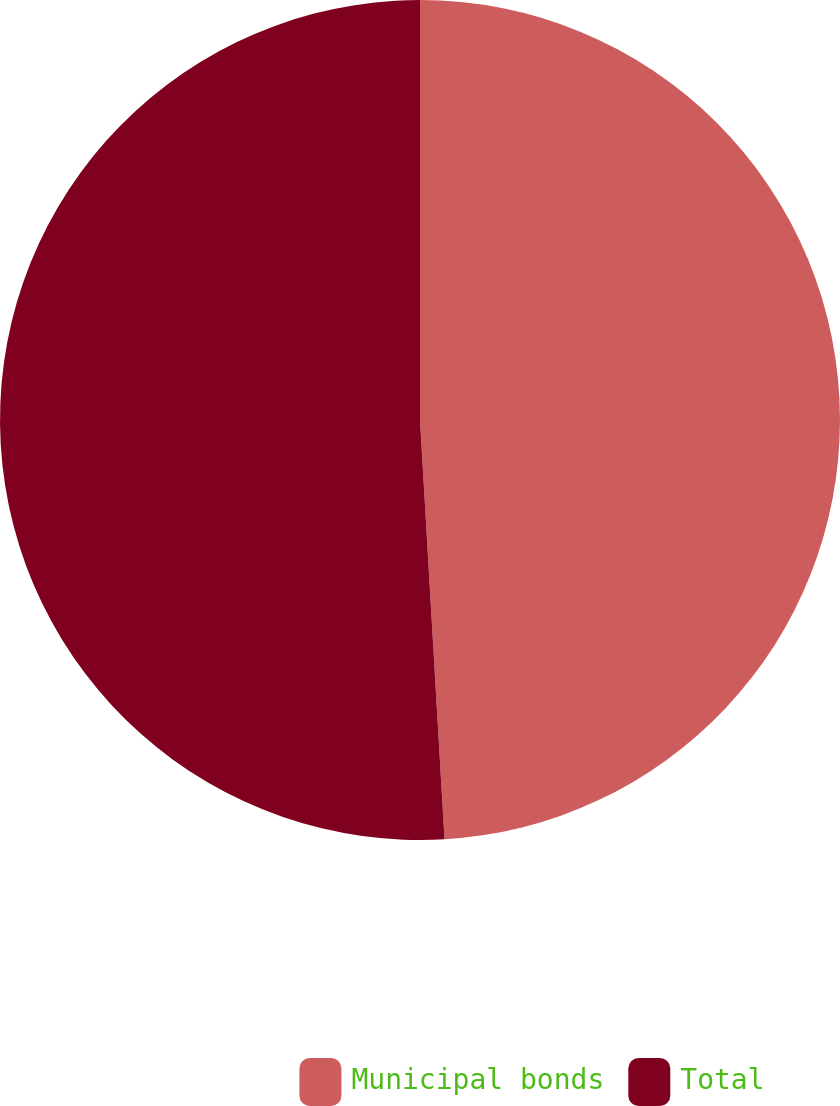<chart> <loc_0><loc_0><loc_500><loc_500><pie_chart><fcel>Municipal bonds<fcel>Total<nl><fcel>49.07%<fcel>50.93%<nl></chart> 